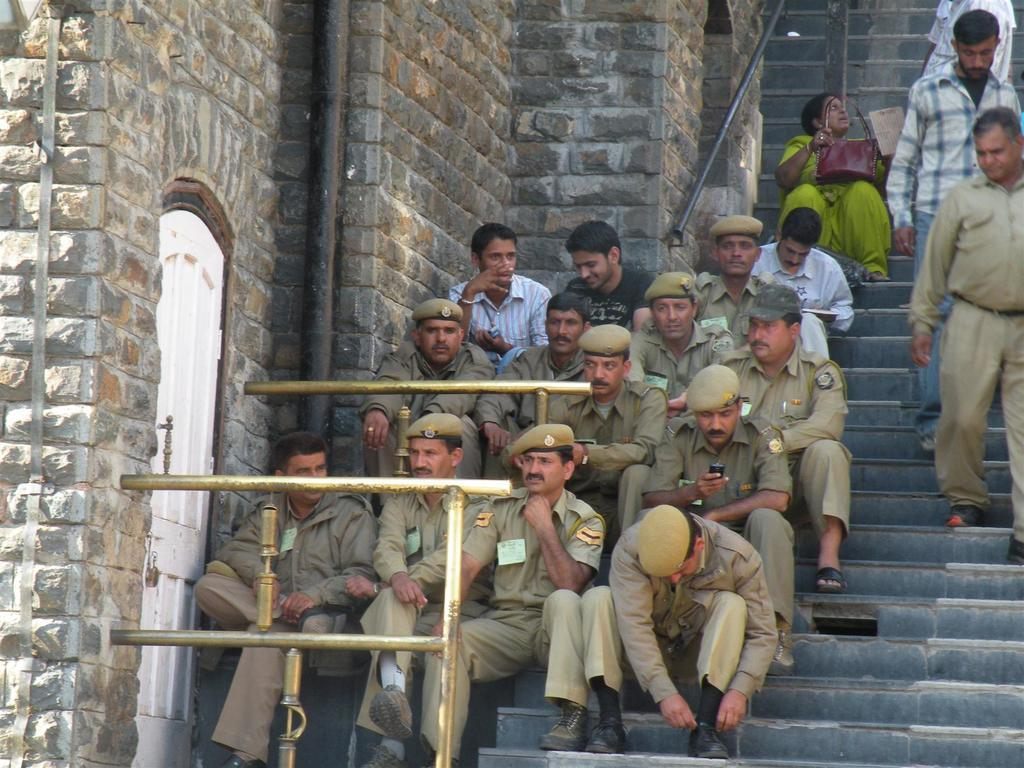What are the people in the image doing? There is a group of people sitting on the stairs, and there are people walking downstairs. What can be seen on the left side of the image? There is a door, a pole, and a wall with stones on the left side of the image. What type of yarn is being used to decorate the stairs in the image? There is no yarn present in the image; it features a group of people sitting on the stairs and people walking downstairs. How many clovers can be seen growing on the wall in the image? There are no clovers present in the image; it features a door, a pole, and a wall with stones on the left side. 